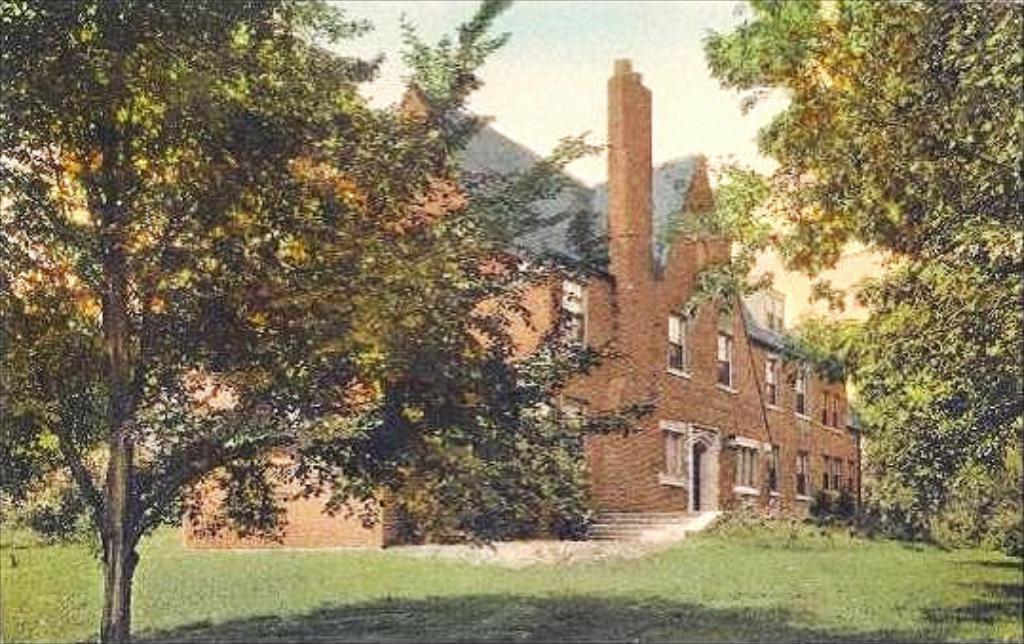Please provide a concise description of this image. In the foreground of this image, there is grass land and on either side, there are trees. Behind it, there is a building. At the top, there is the sky. 